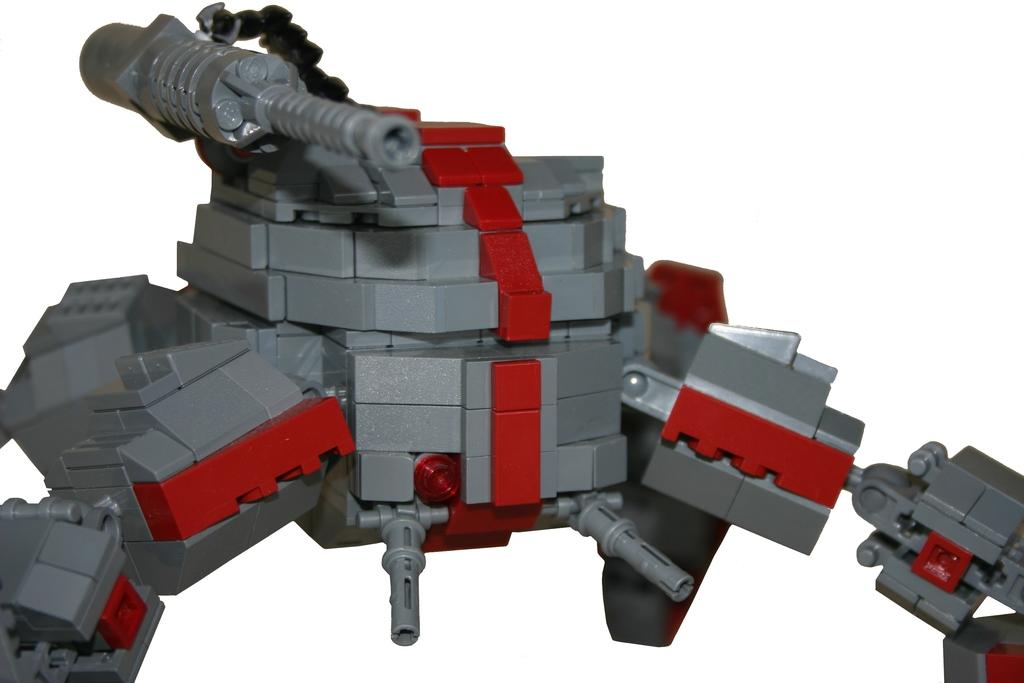What is the main object in the picture? There is a toy in the picture. What color is the background of the image? The background of the image is white. How many suggestions are given in the image? There are no suggestions present in the image; it features a toy and a white background. What type of receipt can be seen in the image? There is no receipt present in the image. 